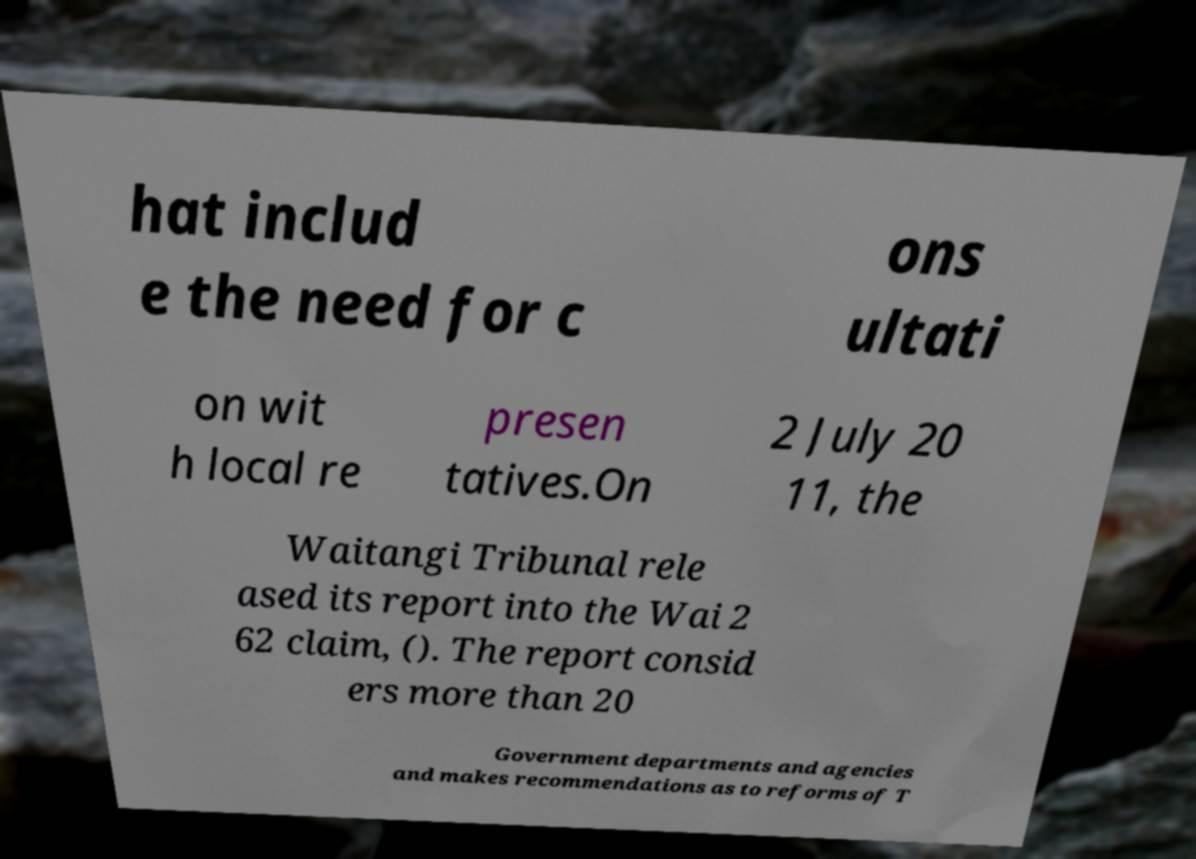What messages or text are displayed in this image? I need them in a readable, typed format. hat includ e the need for c ons ultati on wit h local re presen tatives.On 2 July 20 11, the Waitangi Tribunal rele ased its report into the Wai 2 62 claim, (). The report consid ers more than 20 Government departments and agencies and makes recommendations as to reforms of T 